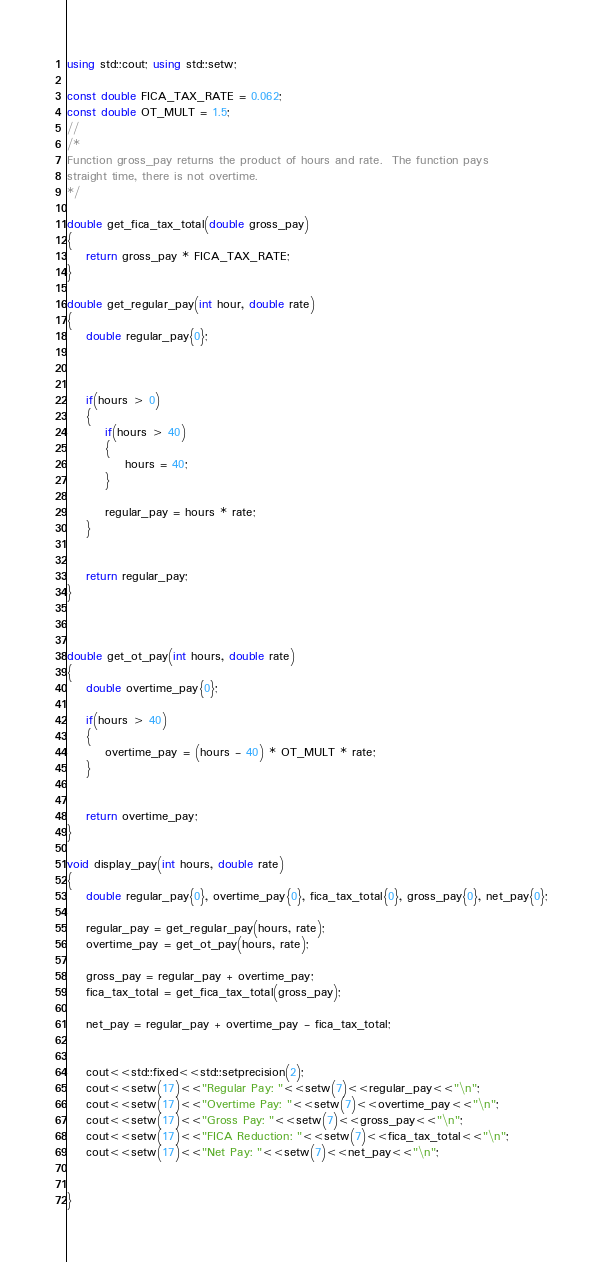Convert code to text. <code><loc_0><loc_0><loc_500><loc_500><_C++_>using std::cout; using std::setw;

const double FICA_TAX_RATE = 0.062;
const double OT_MULT = 1.5;
//
/*
Function gross_pay returns the product of hours and rate.  The function pays
straight time, there is not overtime.
*/

double get_fica_tax_total(double gross_pay)
{
    return gross_pay * FICA_TAX_RATE;
}

double get_regular_pay(int hour, double rate)
{
    double regular_pay{0};


    
    if(hours > 0)
    {
        if(hours > 40)
        {
            hours = 40;
        }

        regular_pay = hours * rate;
    }


    return regular_pay;
}



double get_ot_pay(int hours, double rate)
{
    double overtime_pay{0};

    if(hours > 40)
    {
        overtime_pay = (hours - 40) * OT_MULT * rate;
    }
    

    return overtime_pay;
}

void display_pay(int hours, double rate)
{
    double regular_pay{0}, overtime_pay{0}, fica_tax_total{0}, gross_pay{0}, net_pay{0};

    regular_pay = get_regular_pay(hours, rate);
    overtime_pay = get_ot_pay(hours, rate);
    
    gross_pay = regular_pay + overtime_pay;
    fica_tax_total = get_fica_tax_total(gross_pay);

    net_pay = regular_pay + overtime_pay - fica_tax_total;


    cout<<std::fixed<<std::setprecision(2);
    cout<<setw(17)<<"Regular Pay: "<<setw(7)<<regular_pay<<"\n";
    cout<<setw(17)<<"Overtime Pay: "<<setw(7)<<overtime_pay<<"\n";
    cout<<setw(17)<<"Gross Pay: "<<setw(7)<<gross_pay<<"\n";
    cout<<setw(17)<<"FICA Reduction: "<<setw(7)<<fica_tax_total<<"\n";
    cout<<setw(17)<<"Net Pay: "<<setw(7)<<net_pay<<"\n";


}</code> 